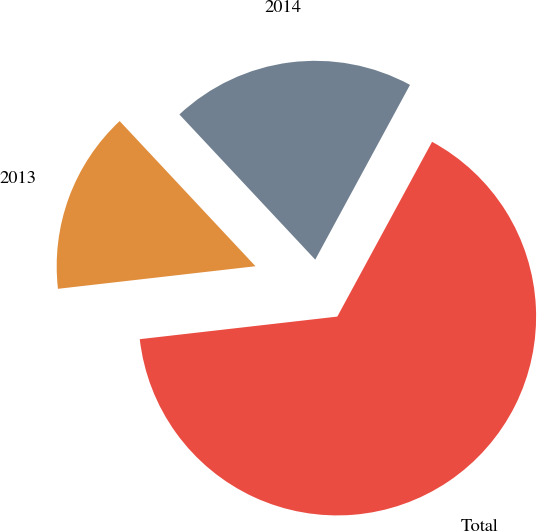Convert chart. <chart><loc_0><loc_0><loc_500><loc_500><pie_chart><fcel>2013<fcel>2014<fcel>Total<nl><fcel>14.84%<fcel>19.88%<fcel>65.28%<nl></chart> 